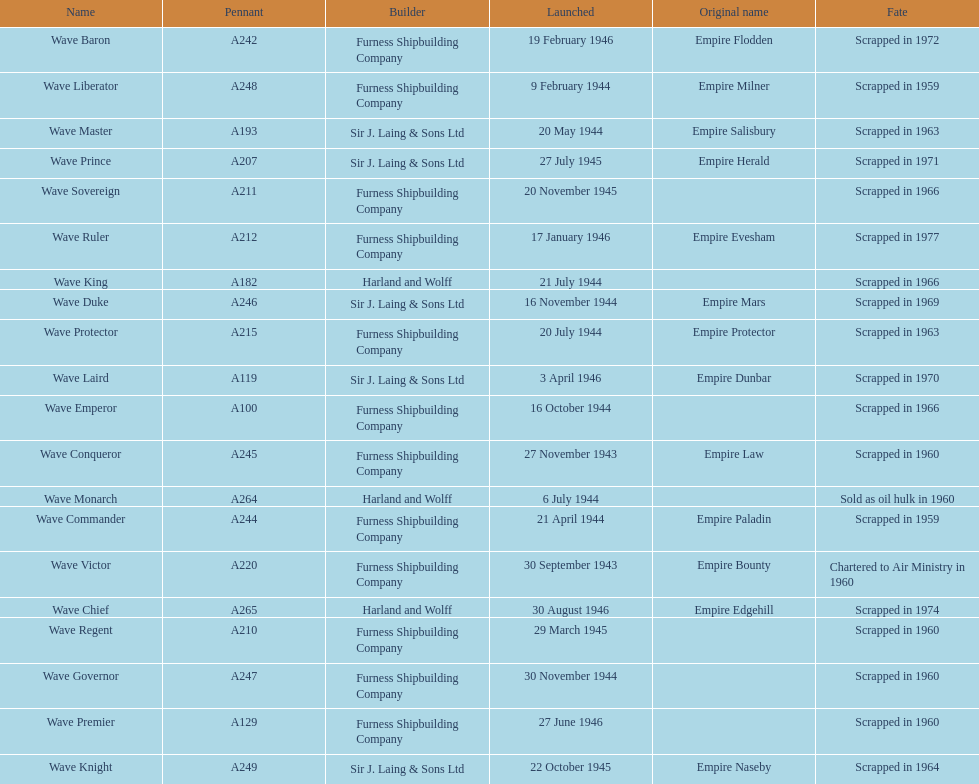Name a builder with "and" in the name. Harland and Wolff. Help me parse the entirety of this table. {'header': ['Name', 'Pennant', 'Builder', 'Launched', 'Original name', 'Fate'], 'rows': [['Wave Baron', 'A242', 'Furness Shipbuilding Company', '19 February 1946', 'Empire Flodden', 'Scrapped in 1972'], ['Wave Liberator', 'A248', 'Furness Shipbuilding Company', '9 February 1944', 'Empire Milner', 'Scrapped in 1959'], ['Wave Master', 'A193', 'Sir J. Laing & Sons Ltd', '20 May 1944', 'Empire Salisbury', 'Scrapped in 1963'], ['Wave Prince', 'A207', 'Sir J. Laing & Sons Ltd', '27 July 1945', 'Empire Herald', 'Scrapped in 1971'], ['Wave Sovereign', 'A211', 'Furness Shipbuilding Company', '20 November 1945', '', 'Scrapped in 1966'], ['Wave Ruler', 'A212', 'Furness Shipbuilding Company', '17 January 1946', 'Empire Evesham', 'Scrapped in 1977'], ['Wave King', 'A182', 'Harland and Wolff', '21 July 1944', '', 'Scrapped in 1966'], ['Wave Duke', 'A246', 'Sir J. Laing & Sons Ltd', '16 November 1944', 'Empire Mars', 'Scrapped in 1969'], ['Wave Protector', 'A215', 'Furness Shipbuilding Company', '20 July 1944', 'Empire Protector', 'Scrapped in 1963'], ['Wave Laird', 'A119', 'Sir J. Laing & Sons Ltd', '3 April 1946', 'Empire Dunbar', 'Scrapped in 1970'], ['Wave Emperor', 'A100', 'Furness Shipbuilding Company', '16 October 1944', '', 'Scrapped in 1966'], ['Wave Conqueror', 'A245', 'Furness Shipbuilding Company', '27 November 1943', 'Empire Law', 'Scrapped in 1960'], ['Wave Monarch', 'A264', 'Harland and Wolff', '6 July 1944', '', 'Sold as oil hulk in 1960'], ['Wave Commander', 'A244', 'Furness Shipbuilding Company', '21 April 1944', 'Empire Paladin', 'Scrapped in 1959'], ['Wave Victor', 'A220', 'Furness Shipbuilding Company', '30 September 1943', 'Empire Bounty', 'Chartered to Air Ministry in 1960'], ['Wave Chief', 'A265', 'Harland and Wolff', '30 August 1946', 'Empire Edgehill', 'Scrapped in 1974'], ['Wave Regent', 'A210', 'Furness Shipbuilding Company', '29 March 1945', '', 'Scrapped in 1960'], ['Wave Governor', 'A247', 'Furness Shipbuilding Company', '30 November 1944', '', 'Scrapped in 1960'], ['Wave Premier', 'A129', 'Furness Shipbuilding Company', '27 June 1946', '', 'Scrapped in 1960'], ['Wave Knight', 'A249', 'Sir J. Laing & Sons Ltd', '22 October 1945', 'Empire Naseby', 'Scrapped in 1964']]} 